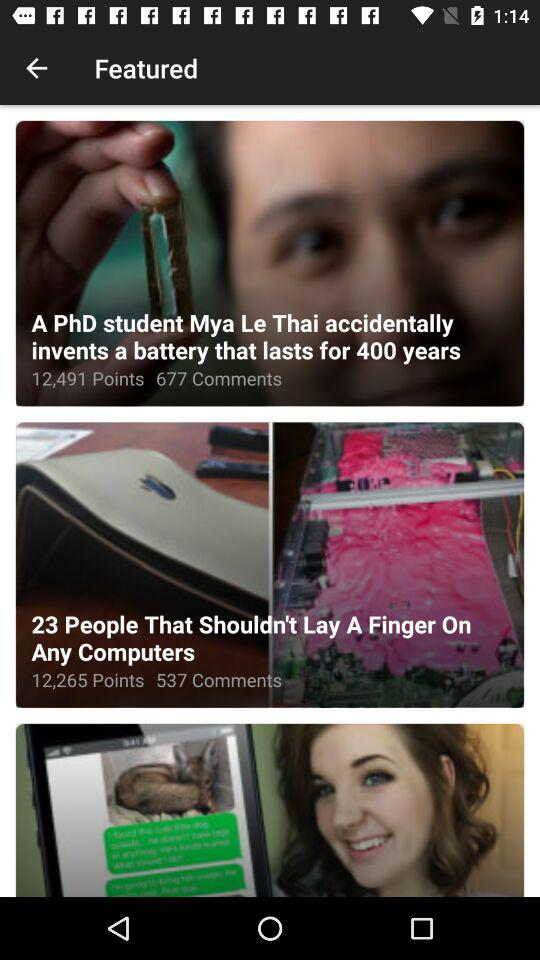How many points are there for the "23 People That Shouldn't Lay A Finger On Any Computers"? There are 12,265 points. 